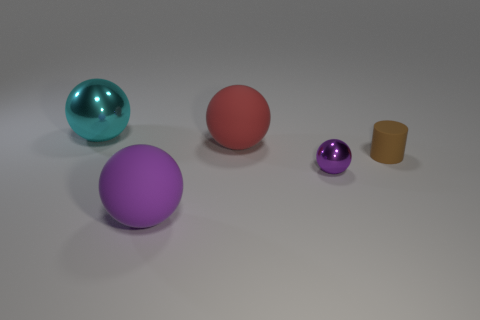There is a rubber object that is the same size as the red sphere; what is its color?
Ensure brevity in your answer.  Purple. What number of metal objects are tiny brown things or small gray spheres?
Keep it short and to the point. 0. How many things are both on the left side of the large red rubber ball and behind the tiny purple object?
Provide a succinct answer. 1. Are there any other things that are the same shape as the small matte thing?
Ensure brevity in your answer.  No. What number of other objects are the same size as the matte cylinder?
Provide a short and direct response. 1. There is a purple thing that is left of the tiny shiny thing; does it have the same size as the brown object behind the tiny metallic sphere?
Provide a short and direct response. No. What number of things are either red blocks or tiny purple metal spheres to the left of the brown cylinder?
Your response must be concise. 1. What size is the shiny object that is in front of the large cyan ball?
Give a very brief answer. Small. Are there fewer large metal balls right of the tiny sphere than large red objects on the right side of the purple rubber sphere?
Provide a short and direct response. Yes. The large thing that is to the left of the red matte ball and behind the small brown matte object is made of what material?
Offer a terse response. Metal. 